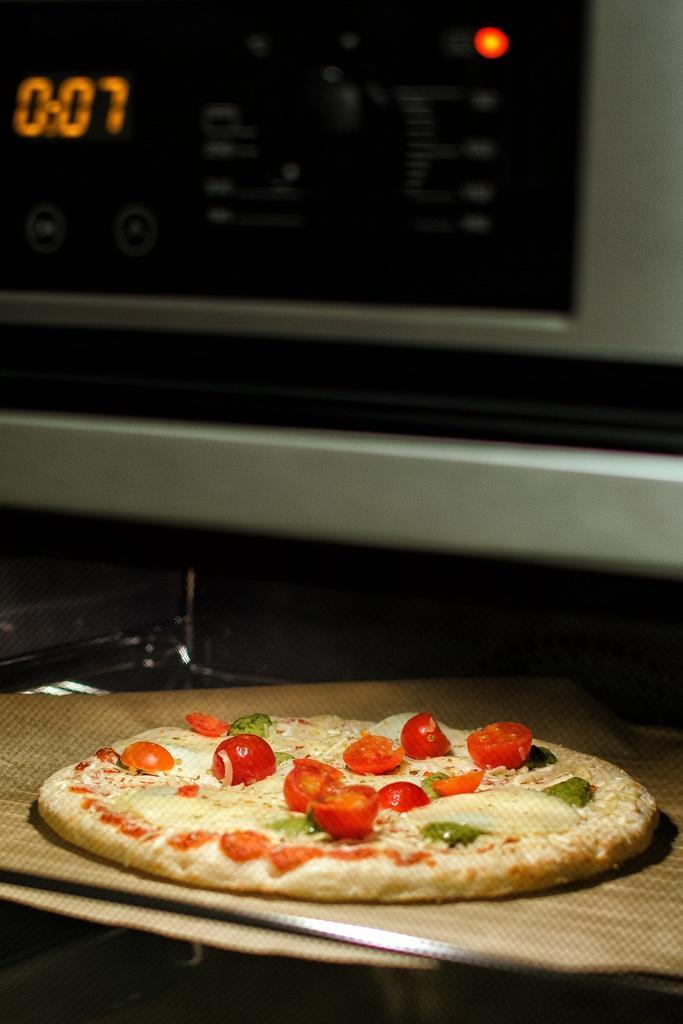Please provide a concise description of this image. In this picture, we can see a pizza on the surface and at the top of the picture we can see a micro own. 